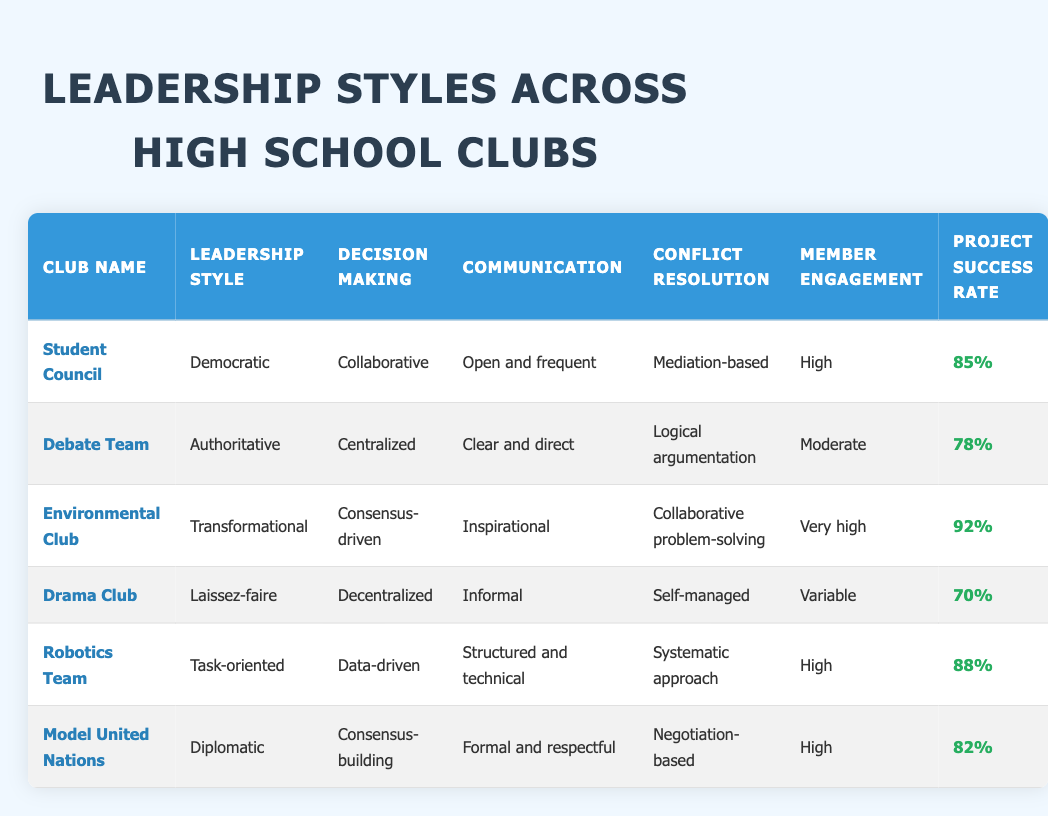What is the project success rate of the Environmental Club? The project success rate for the Environmental Club is listed in the table under the "Project Success Rate" column next to the club's name. The Environmental Club has a success rate of 92%.
Answer: 92% Which club has the highest member engagement? To find the club with the highest member engagement, we can compare the values in the "Member Engagement" column. The Environmental Club is noted as having "Very high" member engagement, which is the highest in the table.
Answer: Environmental Club Is the leadership style of the Debate Team authoritative? By checking the "Leadership Style" column for the Debate Team, it indicates the response is authoritative. Thus the statement is true.
Answer: Yes What is the average project success rate of clubs with high member engagement? The clubs with high member engagement are the Student Council, Environmental Club, and Robotics Team. Their project success rates are 85%, 92%, and 88%, respectively. To find the average, first sum these rates (85 + 92 + 88 = 265) and then divide by the number of clubs (265/3 = 88.33).
Answer: 88.33% Which club has a decentralized decision-making process? The "Decision Making" column indicates a decentralized approach for the Drama Club. Checking this value confirms the statement is accurate.
Answer: Drama Club Are there any clubs with a project success rate above 80%? We can check each club's project success rates in the table and find that the Environmental Club (92%), Robotics Team (88%), and Student Council (85%) all exceed 80%. Therefore, the answer to this question is yes.
Answer: Yes What differences exist in decision-making styles between the Environmental Club and the Debate Team? The Environmental Club employs a consensus-driven decision-making style, while the Debate Team uses a centralized approach. These two methods reflect fundamentally different approaches to gathering input from club members and making decisions.
Answer: Consensus-driven vs. centralized Which club has the least formal communication style? By reviewing the "Communication" column in the table for each club, the Drama Club is noted for having "Informal" communication, which is the least formal style.
Answer: Drama Club How does the conflict resolution strategy of the Environmental Club differ from that of the Debate Team? Checking the "Conflict Resolution" column, the Environmental Club utilizes collaborative problem-solving, whereas the Debate Team employs logical argumentation. This indicates a distinct difference in how conflicts are approached in these clubs.
Answer: Collaborative vs. logical argumentation 